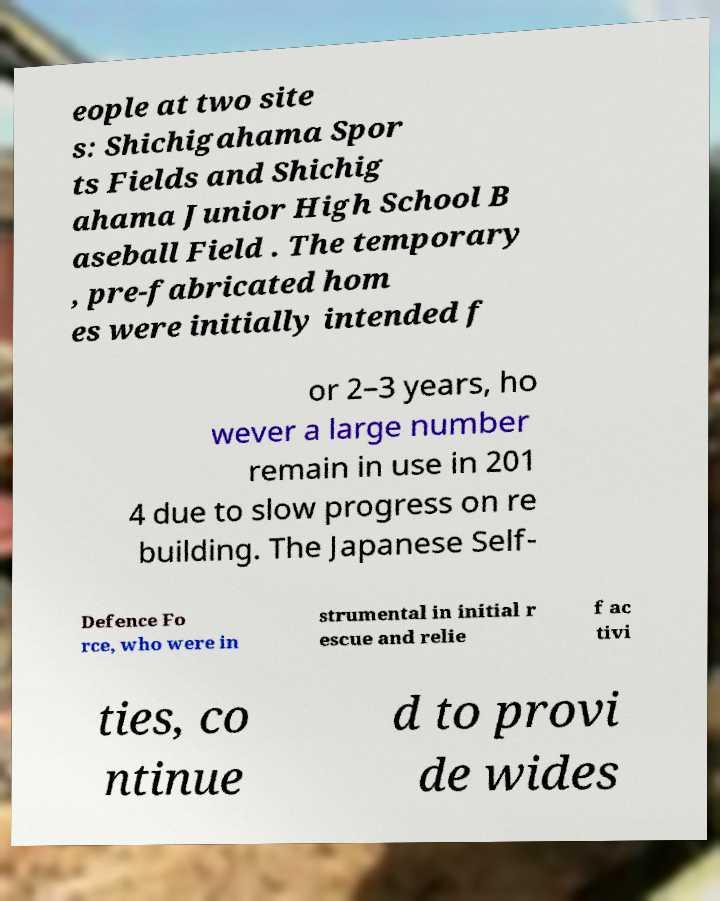There's text embedded in this image that I need extracted. Can you transcribe it verbatim? eople at two site s: Shichigahama Spor ts Fields and Shichig ahama Junior High School B aseball Field . The temporary , pre-fabricated hom es were initially intended f or 2–3 years, ho wever a large number remain in use in 201 4 due to slow progress on re building. The Japanese Self- Defence Fo rce, who were in strumental in initial r escue and relie f ac tivi ties, co ntinue d to provi de wides 